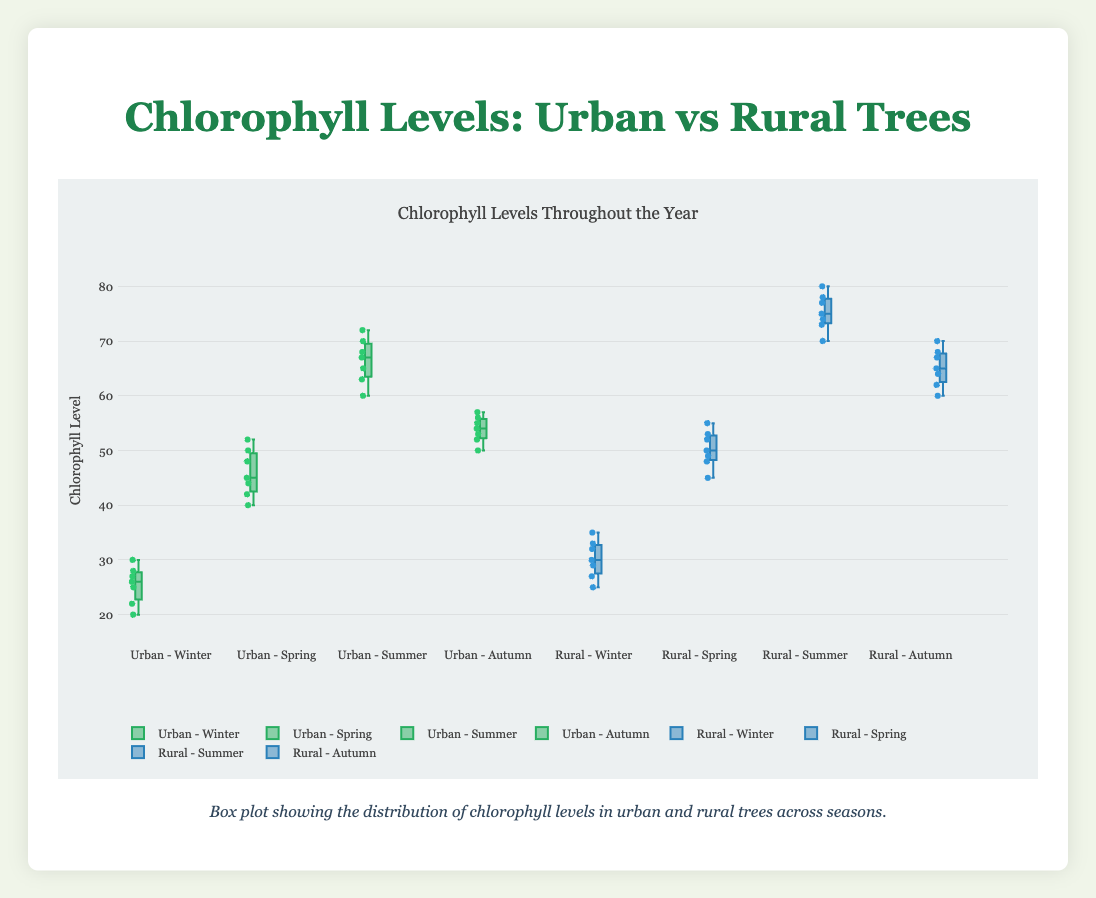What is the overall range of chlorophyll levels observed in urban trees during Winter? The range is calculated as the difference between the maximum and minimum values within the dataset for urban trees during Winter. Observing the box plot, we see the highest value is 30 and the lowest value is 20. The range is 30 - 20.
Answer: 10 Which season shows the highest median chlorophyll level for rural trees? On a box plot, the median is represented by the line inside the box. By comparing the medians for each season, we see the median chlorophyll level is highest in Summer for rural trees.
Answer: Summer Compare the median chlorophyll levels in urban and rural trees during Spring. Which one is higher? Observing the lines representing the medians in the box plots for Spring, the median for rural trees (shown in blue) is higher than that for urban trees (shown in green).
Answer: Rural trees How does the interquartile range (IQR) of chlorophyll levels in Summer compare between urban and rural trees? The IQR is the difference between the upper quartile (75th percentile) and the lower quartile (25th percentile). By comparing the length of the boxes for Summer, the IQR is larger for rural trees compared to urban trees.
Answer: Larger for rural trees During which season is the variance of chlorophyll levels expected to be highest among urban trees? The spread of data points suggests that greater variance occurs where the points are more dispersed. In this case, looking at the overall spread and box dimensions, urban trees in Summer show the greatest dispersion.
Answer: Summer What are the outlier values for chlorophyll levels in rural trees in Autumn? Outliers are usually marked by points outside the whiskers of the box plots. Observing rural trees in Autumn, there are no points outside the whiskers.
Answer: None In which season do urban and rural trees have the closest median chlorophyll levels? By inspecting the medians for both urban and rural trees across the seasons, the medians are closest in Autumn.
Answer: Autumn What is the difference between the upper quartiles of chlorophyll levels in Summer between rural and urban trees? The upper quartile is the top edge of the box in a box plot. For rural trees in Summer, the upper quartile is around 78, and for urban trees, it’s around 70. The difference is 78 - 70.
Answer: 8 